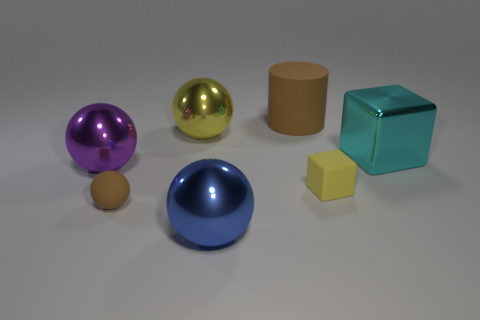Subtract all small brown rubber spheres. How many spheres are left? 3 Subtract 1 spheres. How many spheres are left? 3 Add 1 brown rubber objects. How many objects exist? 8 Subtract all purple spheres. How many spheres are left? 3 Subtract all red spheres. Subtract all cyan cubes. How many spheres are left? 4 Subtract all cyan blocks. Subtract all cyan blocks. How many objects are left? 5 Add 6 yellow rubber objects. How many yellow rubber objects are left? 7 Add 5 gray balls. How many gray balls exist? 5 Subtract 0 yellow cylinders. How many objects are left? 7 Subtract all spheres. How many objects are left? 3 